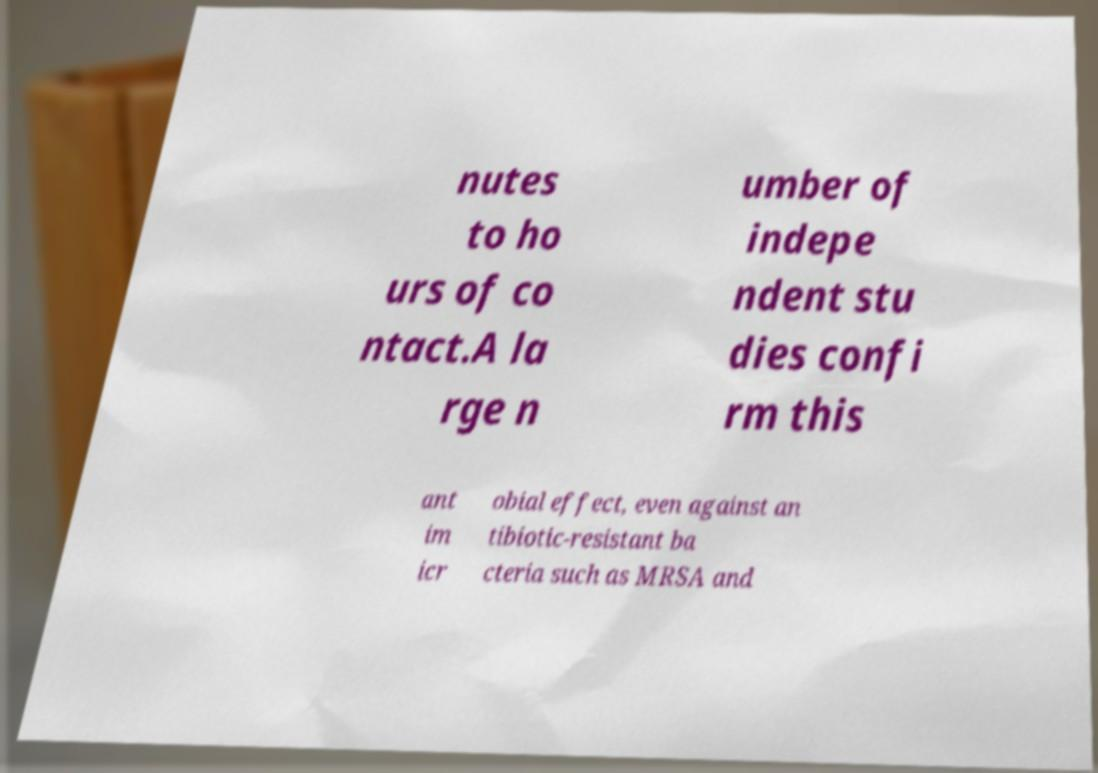For documentation purposes, I need the text within this image transcribed. Could you provide that? nutes to ho urs of co ntact.A la rge n umber of indepe ndent stu dies confi rm this ant im icr obial effect, even against an tibiotic-resistant ba cteria such as MRSA and 